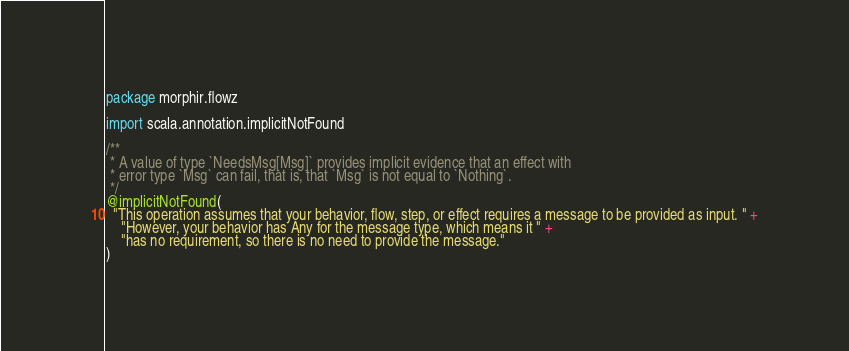<code> <loc_0><loc_0><loc_500><loc_500><_Scala_>package morphir.flowz

import scala.annotation.implicitNotFound

/**
 * A value of type `NeedsMsg[Msg]` provides implicit evidence that an effect with
 * error type `Msg` can fail, that is, that `Msg` is not equal to `Nothing`.
 */
@implicitNotFound(
  "This operation assumes that your behavior, flow, step, or effect requires a message to be provided as input. " +
    "However, your behavior has Any for the message type, which means it " +
    "has no requirement, so there is no need to provide the message."
)</code> 